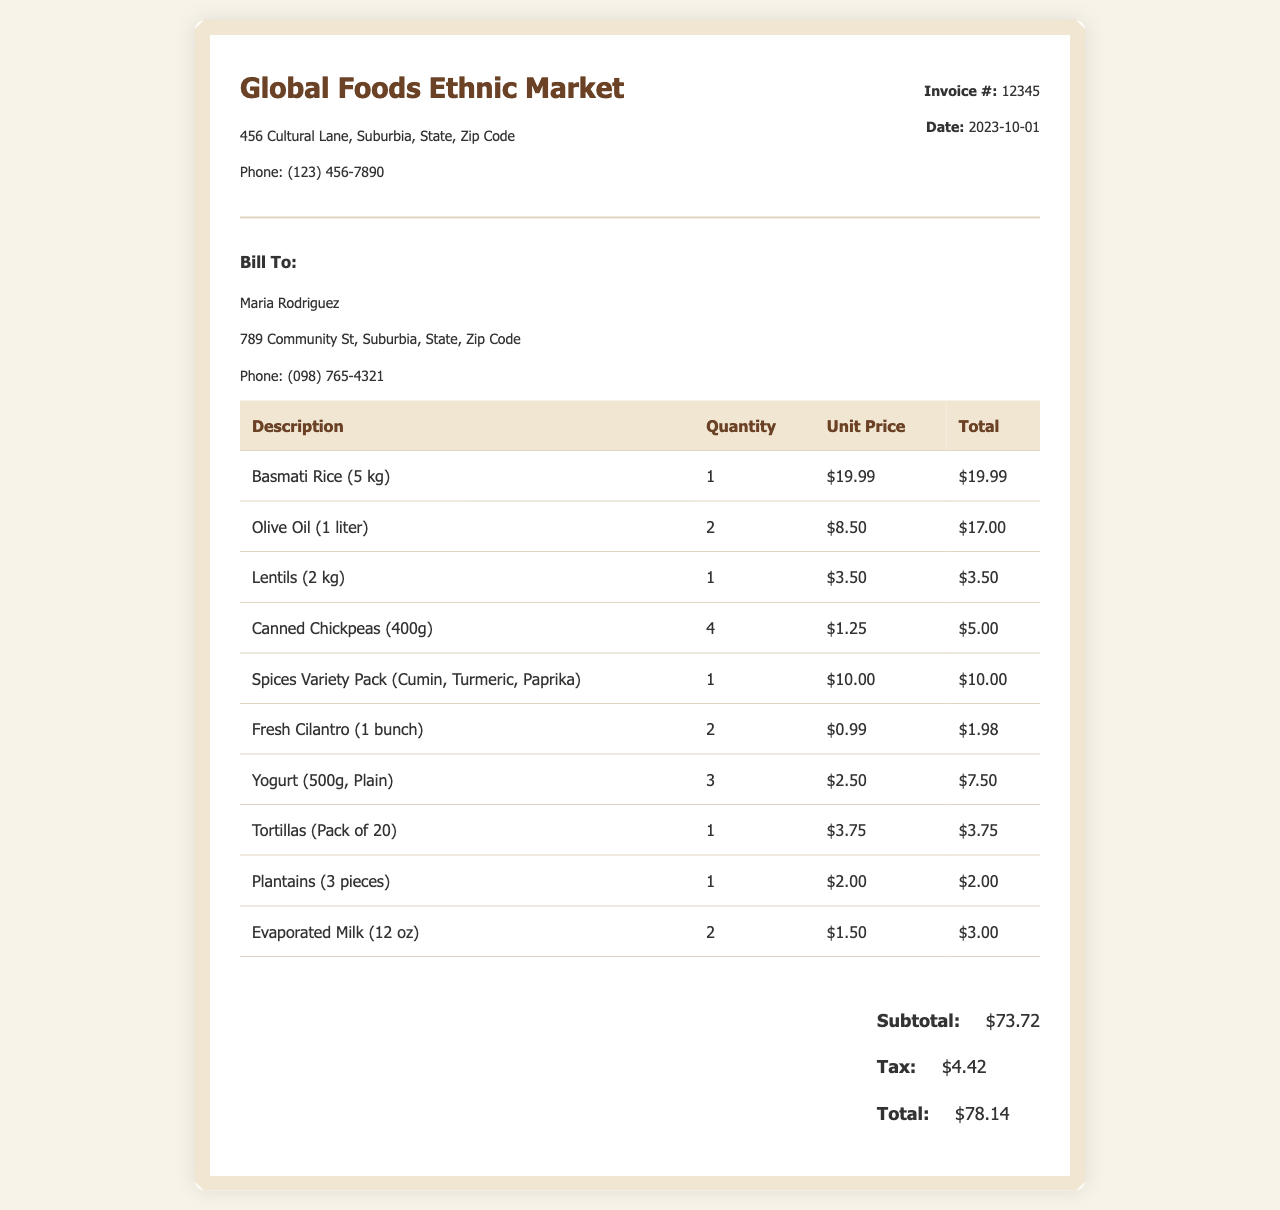What is the invoice number? The invoice number is listed in the details section of the document.
Answer: 12345 What is the total amount due? The total amount due is the last figure in the total section after tax is added.
Answer: $78.14 Who is the bill to? The name of the person being billed is found in the customer information section.
Answer: Maria Rodriguez How many kilograms of Basmati Rice were purchased? The quantity of Basmati Rice can be found in the itemized list of the invoice.
Answer: 1 What is the unit price of Olive Oil? The unit price is listed beside the Olive Oil entry in the table.
Answer: $8.50 What is the tax amount? The tax amount is provided separately in the total section of the invoice.
Answer: $4.42 How many plantains were bought? The quantity of plantains is indicated in the description line for plantains.
Answer: 1 What type of product is included in the Spices Variety Pack? The contents of the Spices Variety Pack are specified in its description.
Answer: Cumin, Turmeric, Paprika What is the address of the store? The store's address is at the top of the invoice under vendor information.
Answer: 456 Cultural Lane, Suburbia, State, Zip Code 